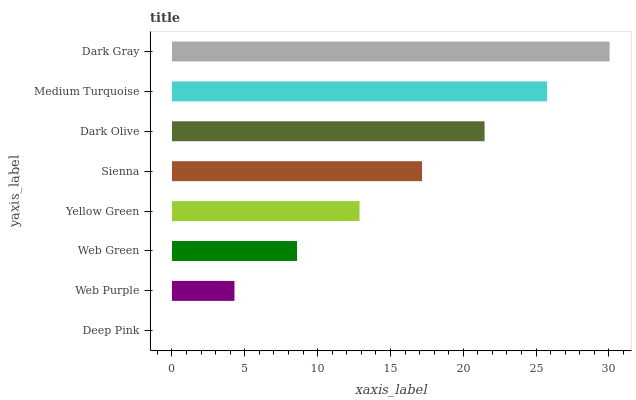Is Deep Pink the minimum?
Answer yes or no. Yes. Is Dark Gray the maximum?
Answer yes or no. Yes. Is Web Purple the minimum?
Answer yes or no. No. Is Web Purple the maximum?
Answer yes or no. No. Is Web Purple greater than Deep Pink?
Answer yes or no. Yes. Is Deep Pink less than Web Purple?
Answer yes or no. Yes. Is Deep Pink greater than Web Purple?
Answer yes or no. No. Is Web Purple less than Deep Pink?
Answer yes or no. No. Is Sienna the high median?
Answer yes or no. Yes. Is Yellow Green the low median?
Answer yes or no. Yes. Is Dark Olive the high median?
Answer yes or no. No. Is Medium Turquoise the low median?
Answer yes or no. No. 